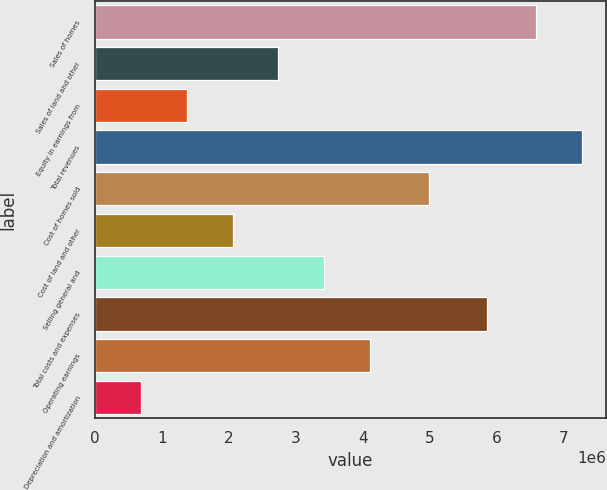<chart> <loc_0><loc_0><loc_500><loc_500><bar_chart><fcel>Sales of homes<fcel>Sales of land and other<fcel>Equity in earnings from<fcel>Total revenues<fcel>Cost of homes sold<fcel>Cost of land and other<fcel>Selling general and<fcel>Total costs and expenses<fcel>Operating earnings<fcel>Depreciation and amortization<nl><fcel>6.5817e+06<fcel>2.73691e+06<fcel>1.37069e+06<fcel>7.26481e+06<fcel>4.98273e+06<fcel>2.0538e+06<fcel>3.42002e+06<fcel>5.85596e+06<fcel>4.10314e+06<fcel>687578<nl></chart> 